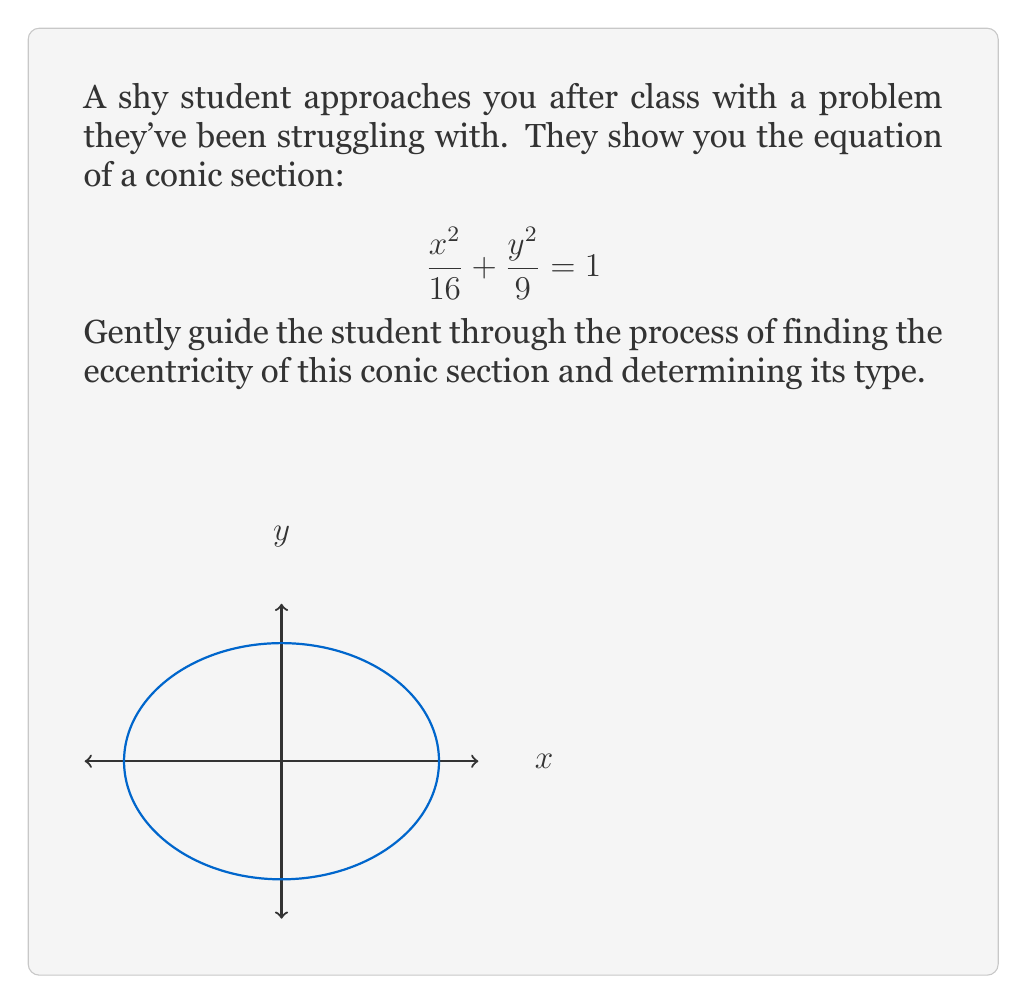Show me your answer to this math problem. Let's approach this step-by-step:

1) First, we need to identify the general form of this equation. It's in the standard form of an ellipse:

   $$\frac{x^2}{a^2} + \frac{y^2}{b^2} = 1$$

   where $a$ and $b$ are the lengths of the semi-major and semi-minor axes.

2) From our equation, we can see that:
   $a^2 = 16$, so $a = 4$
   $b^2 = 9$, so $b = 3$

3) The eccentricity ($e$) of an ellipse is given by the formula:

   $$e = \sqrt{1 - \frac{b^2}{a^2}}$$

4) Let's substitute our values:

   $$e = \sqrt{1 - \frac{3^2}{4^2}}$$

5) Simplify:
   $$e = \sqrt{1 - \frac{9}{16}} = \sqrt{\frac{16-9}{16}} = \sqrt{\frac{7}{16}}$$

6) To determine the type of conic section:
   - If $e = 0$, it's a circle
   - If $0 < e < 1$, it's an ellipse
   - If $e = 1$, it's a parabola
   - If $e > 1$, it's a hyperbola

   Since $0 < \sqrt{\frac{7}{16}} < 1$, this is an ellipse.
Answer: Eccentricity: $e = \sqrt{\frac{7}{16}}$; Type: Ellipse 